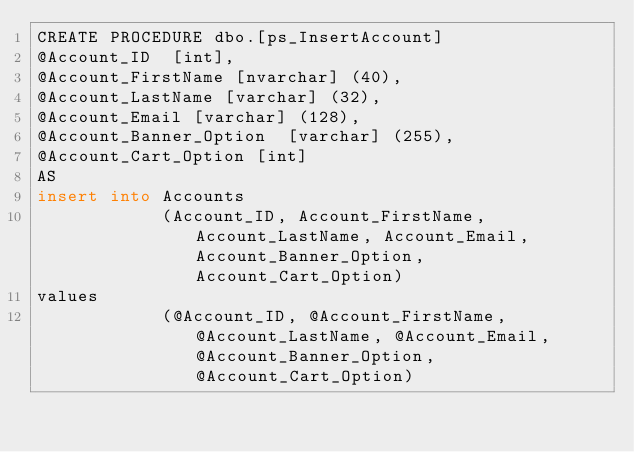Convert code to text. <code><loc_0><loc_0><loc_500><loc_500><_SQL_>CREATE PROCEDURE dbo.[ps_InsertAccount]
@Account_ID  [int], 
@Account_FirstName [nvarchar] (40),
@Account_LastName [varchar] (32),
@Account_Email [varchar] (128),
@Account_Banner_Option  [varchar] (255),
@Account_Cart_Option [int]
AS
insert into Accounts  
			(Account_ID, Account_FirstName, Account_LastName, Account_Email, Account_Banner_Option, Account_Cart_Option) 
values 
			(@Account_ID, @Account_FirstName, @Account_LastName, @Account_Email, @Account_Banner_Option, @Account_Cart_Option)
</code> 